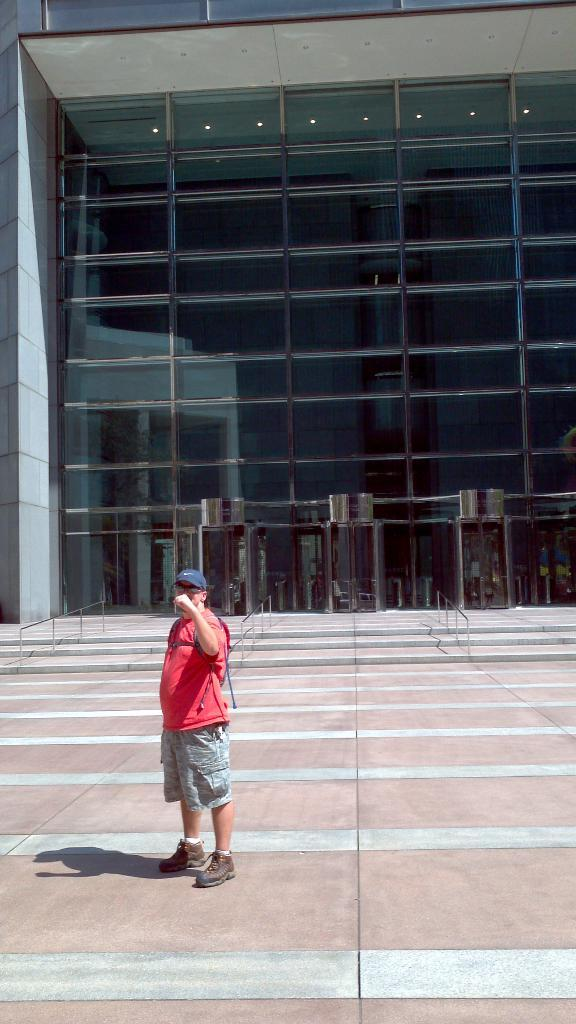What is the man in the image doing? The man is standing in the image. What is the man wearing on his head? The man is wearing a cap. What is the man wearing to protect his eyes? The man is wearing goggles. What can be seen in the background of the image? There are railings, steps, a building, and lights in the background of the image. What type of letters is the man holding in the image? There are no letters visible in the image; the man is not holding anything. 